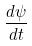<formula> <loc_0><loc_0><loc_500><loc_500>\frac { d \psi } { d t }</formula> 